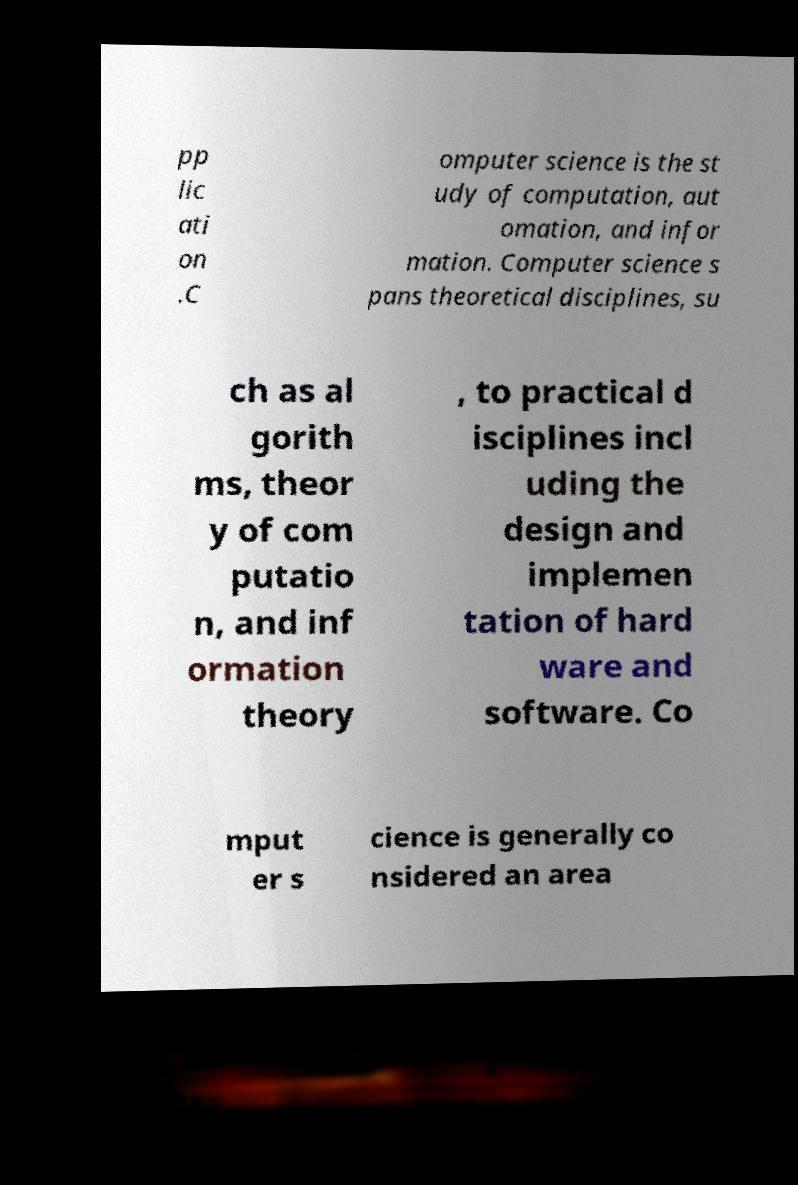Can you accurately transcribe the text from the provided image for me? pp lic ati on .C omputer science is the st udy of computation, aut omation, and infor mation. Computer science s pans theoretical disciplines, su ch as al gorith ms, theor y of com putatio n, and inf ormation theory , to practical d isciplines incl uding the design and implemen tation of hard ware and software. Co mput er s cience is generally co nsidered an area 